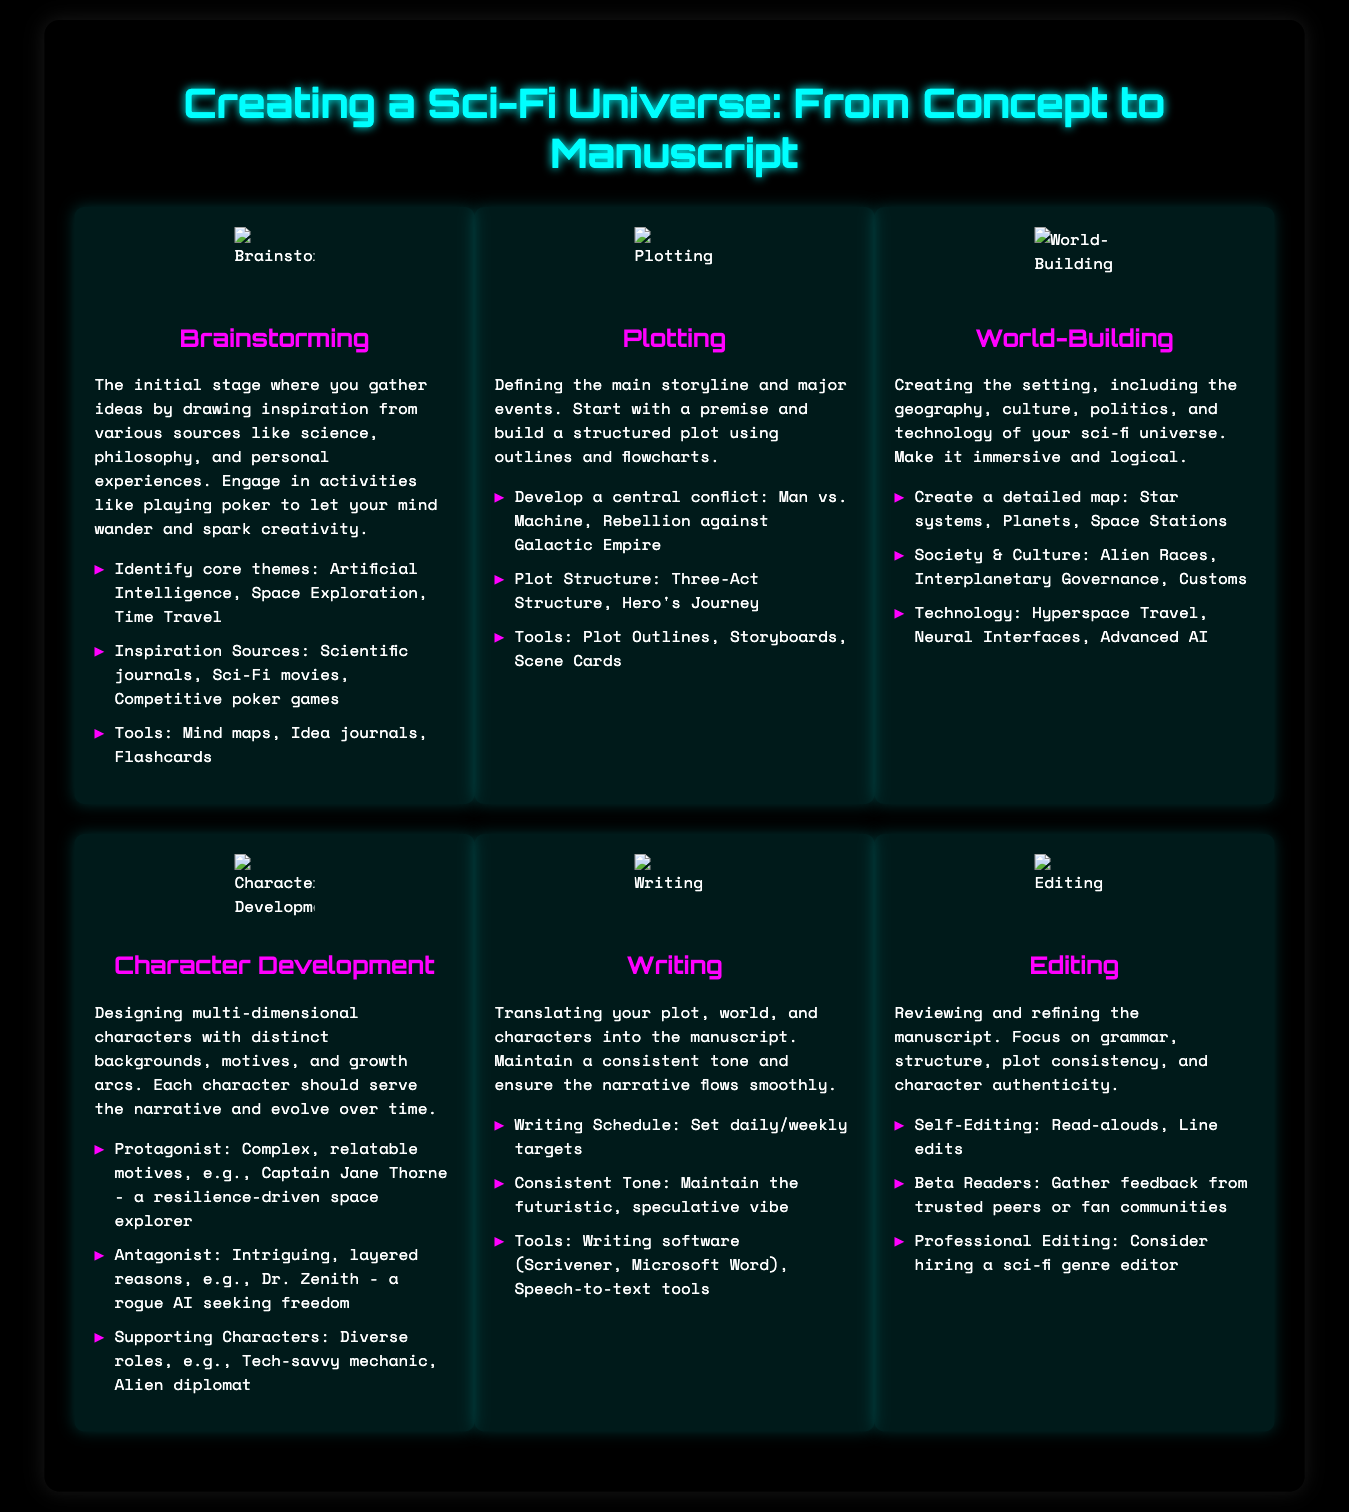What is the first stage of creating a sci-fi universe? The first stage is described as brainstorming, which gathers ideas from various sources.
Answer: Brainstorming What tools are suggested for plotting? The document lists tools such as plot outlines, storyboards, and scene cards for the plotting stage.
Answer: Plot Outlines, Storyboards, Scene Cards What is a key aspect of world-building? A key aspect of world-building is creating a detailed map that includes star systems, planets, and space stations.
Answer: Detailed map Who is an example of a protagonist mentioned? The protagonist example given is Captain Jane Thorne, described as a space explorer driven by resilience.
Answer: Captain Jane Thorne What are beta readers used for in the editing stage? Beta readers are utilized to gather feedback from trusted peers or fan communities.
Answer: Feedback How many key points are listed under character development? There are three key points listed under character development in the document.
Answer: Three What is the purpose of self-editing? The purpose of self-editing is to review the manuscript for grammar, structure, and authenticity.
Answer: Reviewing the manuscript Which writing tool is mentioned as commonly used? The writing tool mentioned is Scrivener, which is popular among writers for manuscript creation.
Answer: Scrivener 